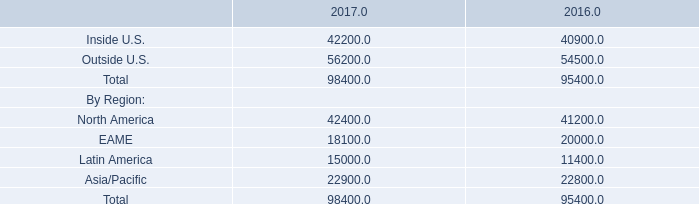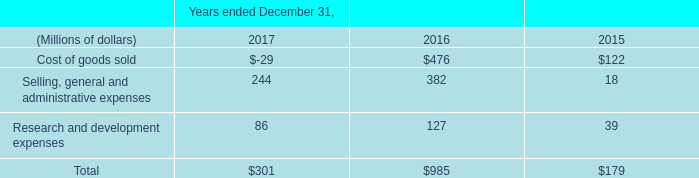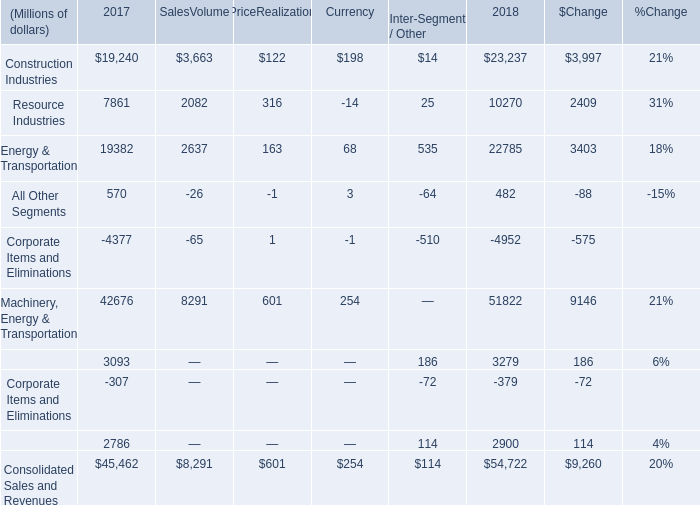what is the expected growth rate in pension and opb contributions from 2017 to 2018? 
Computations: ((365 - (1000 * 1.6)) / (1000 * 1.6))
Answer: -0.77187. 